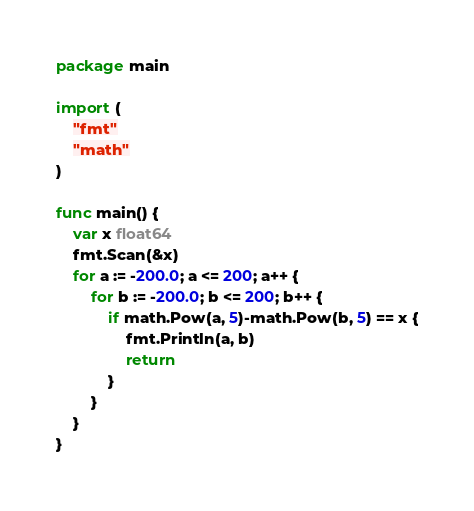Convert code to text. <code><loc_0><loc_0><loc_500><loc_500><_Go_>package main

import (
	"fmt"
	"math"
)

func main() {
	var x float64
	fmt.Scan(&x)
	for a := -200.0; a <= 200; a++ {
		for b := -200.0; b <= 200; b++ {
			if math.Pow(a, 5)-math.Pow(b, 5) == x {
				fmt.Println(a, b)
				return
			}
		}
	}
}
</code> 